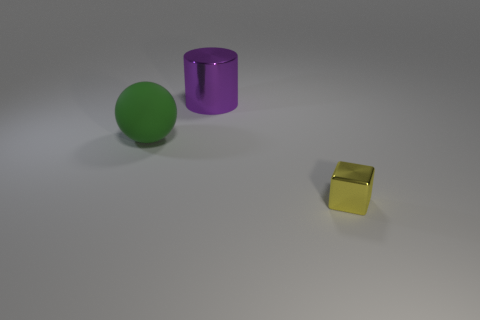What number of cylinders are yellow metallic objects or large green rubber objects?
Your answer should be compact. 0. Are there fewer cylinders to the right of the cylinder than large yellow cylinders?
Ensure brevity in your answer.  No. There is a large thing that is made of the same material as the yellow cube; what shape is it?
Your answer should be very brief. Cylinder. How many objects are either small brown blocks or big objects?
Provide a succinct answer. 2. The big object that is on the left side of the big object that is to the right of the green object is made of what material?
Make the answer very short. Rubber. Are there any spheres that have the same material as the purple cylinder?
Your response must be concise. No. The thing behind the large object to the left of the metal thing that is on the left side of the small yellow metal block is what shape?
Provide a succinct answer. Cylinder. What is the material of the small object?
Your answer should be very brief. Metal. There is a small thing that is the same material as the purple cylinder; what is its color?
Offer a terse response. Yellow. There is a tiny yellow object in front of the purple cylinder; are there any tiny things in front of it?
Your answer should be compact. No. 